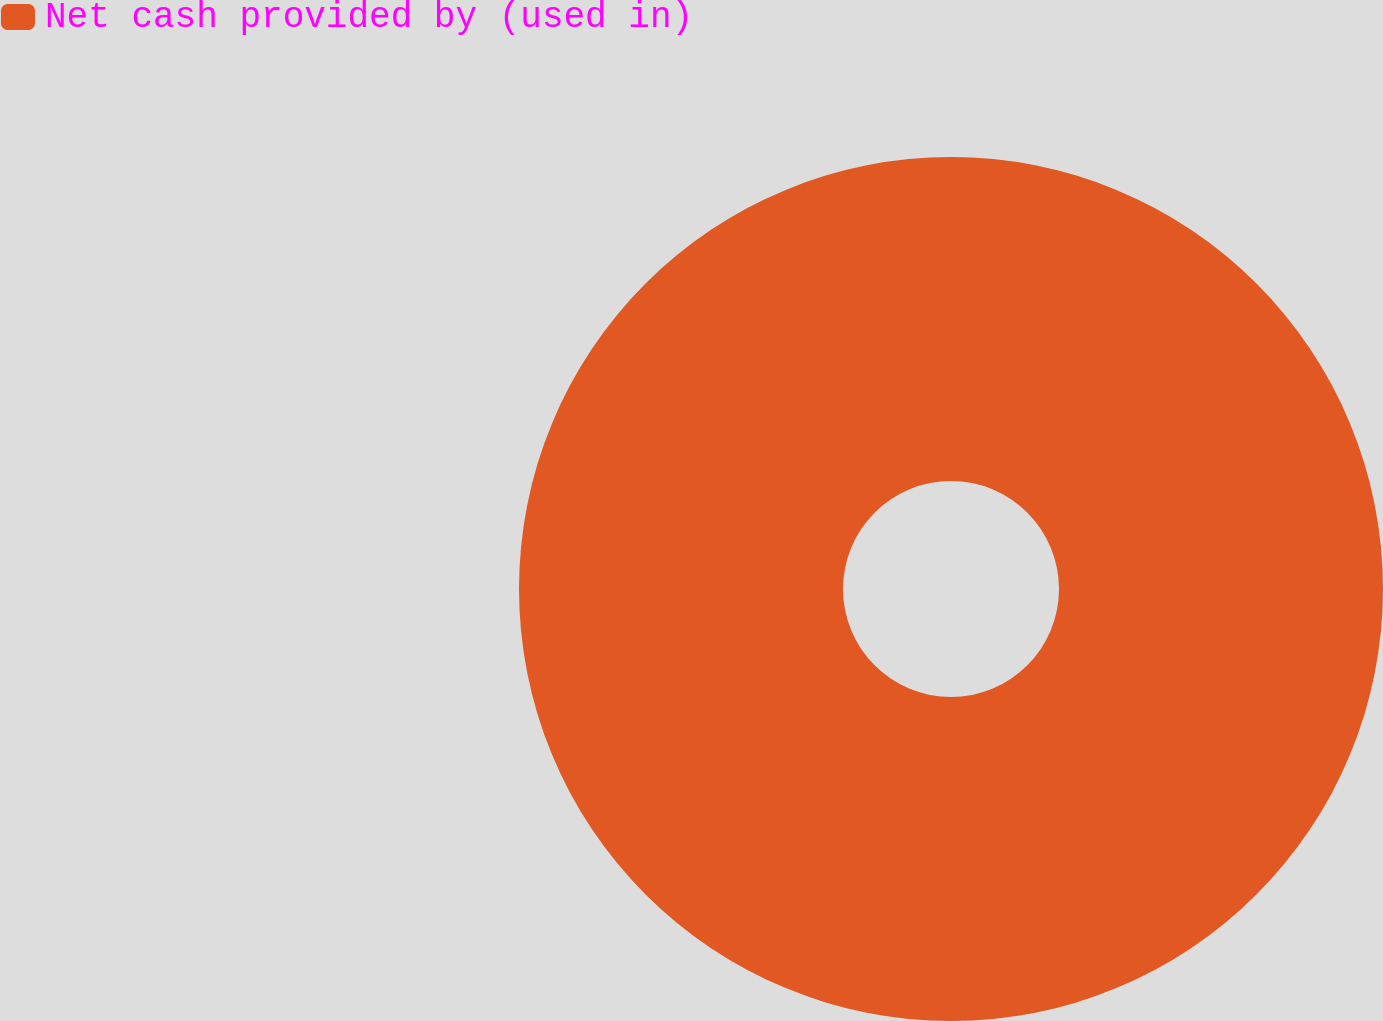Convert chart. <chart><loc_0><loc_0><loc_500><loc_500><pie_chart><fcel>Net cash provided by (used in)<nl><fcel>100.0%<nl></chart> 